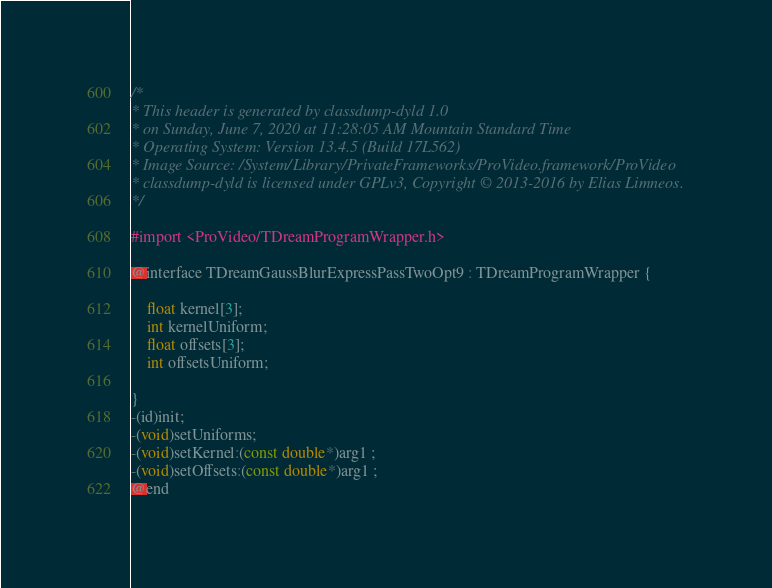Convert code to text. <code><loc_0><loc_0><loc_500><loc_500><_C_>/*
* This header is generated by classdump-dyld 1.0
* on Sunday, June 7, 2020 at 11:28:05 AM Mountain Standard Time
* Operating System: Version 13.4.5 (Build 17L562)
* Image Source: /System/Library/PrivateFrameworks/ProVideo.framework/ProVideo
* classdump-dyld is licensed under GPLv3, Copyright © 2013-2016 by Elias Limneos.
*/

#import <ProVideo/TDreamProgramWrapper.h>

@interface TDreamGaussBlurExpressPassTwoOpt9 : TDreamProgramWrapper {

	float kernel[3];
	int kernelUniform;
	float offsets[3];
	int offsetsUniform;

}
-(id)init;
-(void)setUniforms;
-(void)setKernel:(const double*)arg1 ;
-(void)setOffsets:(const double*)arg1 ;
@end

</code> 